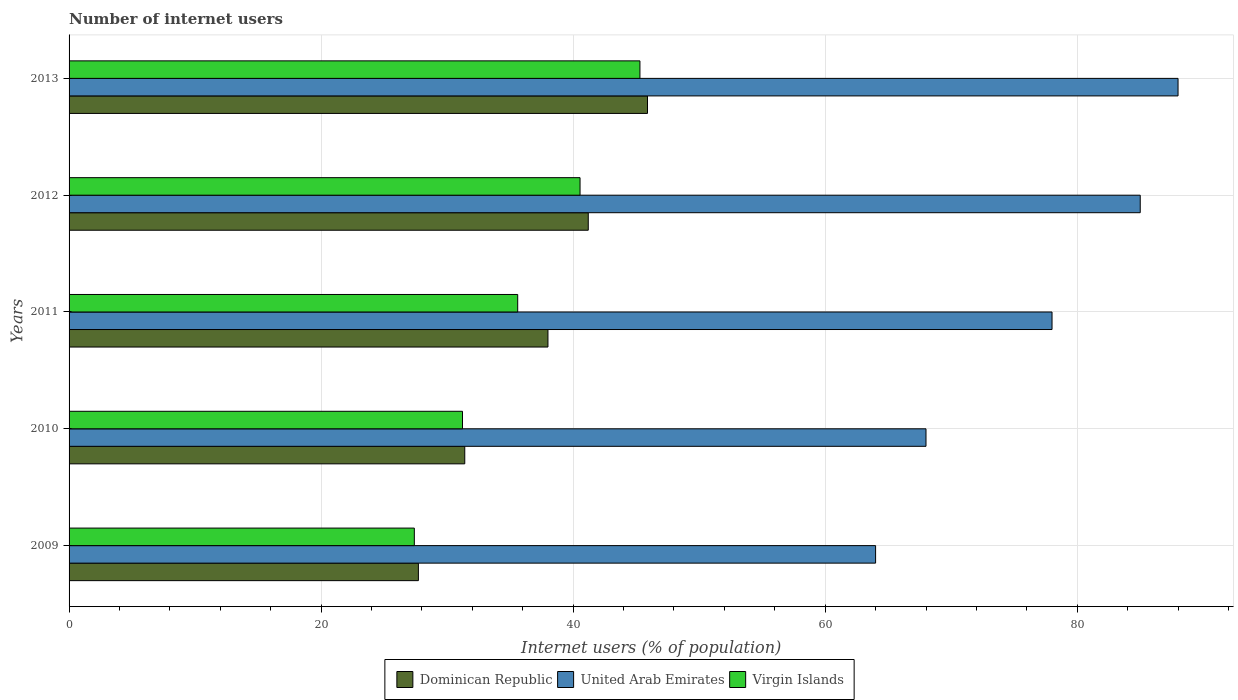How many different coloured bars are there?
Ensure brevity in your answer.  3. How many bars are there on the 3rd tick from the bottom?
Ensure brevity in your answer.  3. What is the label of the 3rd group of bars from the top?
Provide a succinct answer. 2011. In how many cases, is the number of bars for a given year not equal to the number of legend labels?
Offer a terse response. 0. What is the number of internet users in Virgin Islands in 2010?
Your answer should be compact. 31.22. Across all years, what is the maximum number of internet users in Dominican Republic?
Keep it short and to the point. 45.9. Across all years, what is the minimum number of internet users in Virgin Islands?
Make the answer very short. 27.4. What is the total number of internet users in United Arab Emirates in the graph?
Give a very brief answer. 383. What is the difference between the number of internet users in Dominican Republic in 2011 and that in 2013?
Your answer should be very brief. -7.9. What is the difference between the number of internet users in Virgin Islands in 2009 and the number of internet users in United Arab Emirates in 2012?
Your answer should be compact. -57.6. What is the average number of internet users in Virgin Islands per year?
Ensure brevity in your answer.  36.01. In the year 2012, what is the difference between the number of internet users in Dominican Republic and number of internet users in United Arab Emirates?
Offer a very short reply. -43.8. What is the ratio of the number of internet users in Virgin Islands in 2010 to that in 2011?
Provide a short and direct response. 0.88. What is the difference between the highest and the second highest number of internet users in Virgin Islands?
Make the answer very short. 4.75. What is the difference between the highest and the lowest number of internet users in Dominican Republic?
Give a very brief answer. 18.18. In how many years, is the number of internet users in Dominican Republic greater than the average number of internet users in Dominican Republic taken over all years?
Keep it short and to the point. 3. What does the 1st bar from the top in 2009 represents?
Your answer should be very brief. Virgin Islands. What does the 3rd bar from the bottom in 2012 represents?
Make the answer very short. Virgin Islands. How many bars are there?
Your answer should be compact. 15. Are all the bars in the graph horizontal?
Give a very brief answer. Yes. What is the difference between two consecutive major ticks on the X-axis?
Offer a terse response. 20. Are the values on the major ticks of X-axis written in scientific E-notation?
Your answer should be very brief. No. Where does the legend appear in the graph?
Your answer should be compact. Bottom center. How many legend labels are there?
Make the answer very short. 3. How are the legend labels stacked?
Your response must be concise. Horizontal. What is the title of the graph?
Your answer should be compact. Number of internet users. Does "Senegal" appear as one of the legend labels in the graph?
Keep it short and to the point. No. What is the label or title of the X-axis?
Make the answer very short. Internet users (% of population). What is the Internet users (% of population) in Dominican Republic in 2009?
Offer a terse response. 27.72. What is the Internet users (% of population) in Virgin Islands in 2009?
Offer a very short reply. 27.4. What is the Internet users (% of population) of Dominican Republic in 2010?
Keep it short and to the point. 31.4. What is the Internet users (% of population) of Virgin Islands in 2010?
Make the answer very short. 31.22. What is the Internet users (% of population) in Dominican Republic in 2011?
Your response must be concise. 38. What is the Internet users (% of population) in United Arab Emirates in 2011?
Offer a very short reply. 78. What is the Internet users (% of population) in Virgin Islands in 2011?
Your answer should be compact. 35.6. What is the Internet users (% of population) in Dominican Republic in 2012?
Offer a terse response. 41.2. What is the Internet users (% of population) in United Arab Emirates in 2012?
Your answer should be compact. 85. What is the Internet users (% of population) in Virgin Islands in 2012?
Keep it short and to the point. 40.55. What is the Internet users (% of population) of Dominican Republic in 2013?
Your answer should be very brief. 45.9. What is the Internet users (% of population) of United Arab Emirates in 2013?
Your answer should be very brief. 88. What is the Internet users (% of population) in Virgin Islands in 2013?
Offer a very short reply. 45.3. Across all years, what is the maximum Internet users (% of population) in Dominican Republic?
Give a very brief answer. 45.9. Across all years, what is the maximum Internet users (% of population) in United Arab Emirates?
Offer a very short reply. 88. Across all years, what is the maximum Internet users (% of population) in Virgin Islands?
Your answer should be compact. 45.3. Across all years, what is the minimum Internet users (% of population) of Dominican Republic?
Offer a very short reply. 27.72. Across all years, what is the minimum Internet users (% of population) in United Arab Emirates?
Ensure brevity in your answer.  64. Across all years, what is the minimum Internet users (% of population) of Virgin Islands?
Provide a succinct answer. 27.4. What is the total Internet users (% of population) in Dominican Republic in the graph?
Make the answer very short. 184.22. What is the total Internet users (% of population) of United Arab Emirates in the graph?
Your response must be concise. 383. What is the total Internet users (% of population) in Virgin Islands in the graph?
Offer a very short reply. 180.06. What is the difference between the Internet users (% of population) in Dominican Republic in 2009 and that in 2010?
Your answer should be very brief. -3.68. What is the difference between the Internet users (% of population) of United Arab Emirates in 2009 and that in 2010?
Offer a terse response. -4. What is the difference between the Internet users (% of population) in Virgin Islands in 2009 and that in 2010?
Keep it short and to the point. -3.82. What is the difference between the Internet users (% of population) in Dominican Republic in 2009 and that in 2011?
Provide a succinct answer. -10.28. What is the difference between the Internet users (% of population) of Virgin Islands in 2009 and that in 2011?
Ensure brevity in your answer.  -8.2. What is the difference between the Internet users (% of population) in Dominican Republic in 2009 and that in 2012?
Provide a succinct answer. -13.48. What is the difference between the Internet users (% of population) of United Arab Emirates in 2009 and that in 2012?
Provide a succinct answer. -21. What is the difference between the Internet users (% of population) in Virgin Islands in 2009 and that in 2012?
Offer a very short reply. -13.15. What is the difference between the Internet users (% of population) in Dominican Republic in 2009 and that in 2013?
Provide a succinct answer. -18.18. What is the difference between the Internet users (% of population) in United Arab Emirates in 2009 and that in 2013?
Your response must be concise. -24. What is the difference between the Internet users (% of population) of Virgin Islands in 2009 and that in 2013?
Ensure brevity in your answer.  -17.9. What is the difference between the Internet users (% of population) of United Arab Emirates in 2010 and that in 2011?
Offer a very short reply. -10. What is the difference between the Internet users (% of population) of Virgin Islands in 2010 and that in 2011?
Provide a short and direct response. -4.38. What is the difference between the Internet users (% of population) of Virgin Islands in 2010 and that in 2012?
Give a very brief answer. -9.33. What is the difference between the Internet users (% of population) in Dominican Republic in 2010 and that in 2013?
Your answer should be very brief. -14.5. What is the difference between the Internet users (% of population) of United Arab Emirates in 2010 and that in 2013?
Give a very brief answer. -20. What is the difference between the Internet users (% of population) in Virgin Islands in 2010 and that in 2013?
Provide a short and direct response. -14.08. What is the difference between the Internet users (% of population) in United Arab Emirates in 2011 and that in 2012?
Your answer should be very brief. -7. What is the difference between the Internet users (% of population) of Virgin Islands in 2011 and that in 2012?
Your answer should be compact. -4.95. What is the difference between the Internet users (% of population) in Dominican Republic in 2011 and that in 2013?
Provide a short and direct response. -7.9. What is the difference between the Internet users (% of population) in United Arab Emirates in 2011 and that in 2013?
Your answer should be very brief. -10. What is the difference between the Internet users (% of population) of Dominican Republic in 2012 and that in 2013?
Offer a terse response. -4.7. What is the difference between the Internet users (% of population) in Virgin Islands in 2012 and that in 2013?
Provide a short and direct response. -4.75. What is the difference between the Internet users (% of population) in Dominican Republic in 2009 and the Internet users (% of population) in United Arab Emirates in 2010?
Offer a terse response. -40.28. What is the difference between the Internet users (% of population) in United Arab Emirates in 2009 and the Internet users (% of population) in Virgin Islands in 2010?
Your answer should be compact. 32.78. What is the difference between the Internet users (% of population) of Dominican Republic in 2009 and the Internet users (% of population) of United Arab Emirates in 2011?
Offer a terse response. -50.28. What is the difference between the Internet users (% of population) in Dominican Republic in 2009 and the Internet users (% of population) in Virgin Islands in 2011?
Ensure brevity in your answer.  -7.88. What is the difference between the Internet users (% of population) in United Arab Emirates in 2009 and the Internet users (% of population) in Virgin Islands in 2011?
Your response must be concise. 28.4. What is the difference between the Internet users (% of population) of Dominican Republic in 2009 and the Internet users (% of population) of United Arab Emirates in 2012?
Your answer should be very brief. -57.28. What is the difference between the Internet users (% of population) of Dominican Republic in 2009 and the Internet users (% of population) of Virgin Islands in 2012?
Give a very brief answer. -12.83. What is the difference between the Internet users (% of population) of United Arab Emirates in 2009 and the Internet users (% of population) of Virgin Islands in 2012?
Provide a succinct answer. 23.45. What is the difference between the Internet users (% of population) of Dominican Republic in 2009 and the Internet users (% of population) of United Arab Emirates in 2013?
Offer a very short reply. -60.28. What is the difference between the Internet users (% of population) in Dominican Republic in 2009 and the Internet users (% of population) in Virgin Islands in 2013?
Provide a succinct answer. -17.58. What is the difference between the Internet users (% of population) of Dominican Republic in 2010 and the Internet users (% of population) of United Arab Emirates in 2011?
Provide a short and direct response. -46.6. What is the difference between the Internet users (% of population) of Dominican Republic in 2010 and the Internet users (% of population) of Virgin Islands in 2011?
Offer a very short reply. -4.2. What is the difference between the Internet users (% of population) of United Arab Emirates in 2010 and the Internet users (% of population) of Virgin Islands in 2011?
Your answer should be very brief. 32.4. What is the difference between the Internet users (% of population) of Dominican Republic in 2010 and the Internet users (% of population) of United Arab Emirates in 2012?
Keep it short and to the point. -53.6. What is the difference between the Internet users (% of population) of Dominican Republic in 2010 and the Internet users (% of population) of Virgin Islands in 2012?
Your answer should be very brief. -9.15. What is the difference between the Internet users (% of population) in United Arab Emirates in 2010 and the Internet users (% of population) in Virgin Islands in 2012?
Keep it short and to the point. 27.45. What is the difference between the Internet users (% of population) of Dominican Republic in 2010 and the Internet users (% of population) of United Arab Emirates in 2013?
Give a very brief answer. -56.6. What is the difference between the Internet users (% of population) of Dominican Republic in 2010 and the Internet users (% of population) of Virgin Islands in 2013?
Your response must be concise. -13.9. What is the difference between the Internet users (% of population) of United Arab Emirates in 2010 and the Internet users (% of population) of Virgin Islands in 2013?
Your answer should be compact. 22.7. What is the difference between the Internet users (% of population) in Dominican Republic in 2011 and the Internet users (% of population) in United Arab Emirates in 2012?
Make the answer very short. -47. What is the difference between the Internet users (% of population) of Dominican Republic in 2011 and the Internet users (% of population) of Virgin Islands in 2012?
Keep it short and to the point. -2.55. What is the difference between the Internet users (% of population) in United Arab Emirates in 2011 and the Internet users (% of population) in Virgin Islands in 2012?
Give a very brief answer. 37.45. What is the difference between the Internet users (% of population) in Dominican Republic in 2011 and the Internet users (% of population) in Virgin Islands in 2013?
Your response must be concise. -7.3. What is the difference between the Internet users (% of population) in United Arab Emirates in 2011 and the Internet users (% of population) in Virgin Islands in 2013?
Provide a short and direct response. 32.7. What is the difference between the Internet users (% of population) of Dominican Republic in 2012 and the Internet users (% of population) of United Arab Emirates in 2013?
Provide a short and direct response. -46.8. What is the difference between the Internet users (% of population) in Dominican Republic in 2012 and the Internet users (% of population) in Virgin Islands in 2013?
Ensure brevity in your answer.  -4.1. What is the difference between the Internet users (% of population) of United Arab Emirates in 2012 and the Internet users (% of population) of Virgin Islands in 2013?
Give a very brief answer. 39.7. What is the average Internet users (% of population) of Dominican Republic per year?
Offer a terse response. 36.84. What is the average Internet users (% of population) in United Arab Emirates per year?
Provide a short and direct response. 76.6. What is the average Internet users (% of population) of Virgin Islands per year?
Keep it short and to the point. 36.01. In the year 2009, what is the difference between the Internet users (% of population) of Dominican Republic and Internet users (% of population) of United Arab Emirates?
Ensure brevity in your answer.  -36.28. In the year 2009, what is the difference between the Internet users (% of population) of Dominican Republic and Internet users (% of population) of Virgin Islands?
Your answer should be very brief. 0.32. In the year 2009, what is the difference between the Internet users (% of population) in United Arab Emirates and Internet users (% of population) in Virgin Islands?
Make the answer very short. 36.6. In the year 2010, what is the difference between the Internet users (% of population) in Dominican Republic and Internet users (% of population) in United Arab Emirates?
Provide a short and direct response. -36.6. In the year 2010, what is the difference between the Internet users (% of population) of Dominican Republic and Internet users (% of population) of Virgin Islands?
Your response must be concise. 0.18. In the year 2010, what is the difference between the Internet users (% of population) of United Arab Emirates and Internet users (% of population) of Virgin Islands?
Give a very brief answer. 36.78. In the year 2011, what is the difference between the Internet users (% of population) of Dominican Republic and Internet users (% of population) of Virgin Islands?
Offer a very short reply. 2.4. In the year 2011, what is the difference between the Internet users (% of population) in United Arab Emirates and Internet users (% of population) in Virgin Islands?
Make the answer very short. 42.4. In the year 2012, what is the difference between the Internet users (% of population) in Dominican Republic and Internet users (% of population) in United Arab Emirates?
Offer a very short reply. -43.8. In the year 2012, what is the difference between the Internet users (% of population) in Dominican Republic and Internet users (% of population) in Virgin Islands?
Provide a short and direct response. 0.65. In the year 2012, what is the difference between the Internet users (% of population) of United Arab Emirates and Internet users (% of population) of Virgin Islands?
Ensure brevity in your answer.  44.45. In the year 2013, what is the difference between the Internet users (% of population) in Dominican Republic and Internet users (% of population) in United Arab Emirates?
Provide a succinct answer. -42.1. In the year 2013, what is the difference between the Internet users (% of population) of United Arab Emirates and Internet users (% of population) of Virgin Islands?
Give a very brief answer. 42.7. What is the ratio of the Internet users (% of population) of Dominican Republic in 2009 to that in 2010?
Provide a short and direct response. 0.88. What is the ratio of the Internet users (% of population) of Virgin Islands in 2009 to that in 2010?
Provide a succinct answer. 0.88. What is the ratio of the Internet users (% of population) of Dominican Republic in 2009 to that in 2011?
Keep it short and to the point. 0.73. What is the ratio of the Internet users (% of population) of United Arab Emirates in 2009 to that in 2011?
Keep it short and to the point. 0.82. What is the ratio of the Internet users (% of population) of Virgin Islands in 2009 to that in 2011?
Give a very brief answer. 0.77. What is the ratio of the Internet users (% of population) in Dominican Republic in 2009 to that in 2012?
Your answer should be very brief. 0.67. What is the ratio of the Internet users (% of population) in United Arab Emirates in 2009 to that in 2012?
Offer a terse response. 0.75. What is the ratio of the Internet users (% of population) of Virgin Islands in 2009 to that in 2012?
Make the answer very short. 0.68. What is the ratio of the Internet users (% of population) in Dominican Republic in 2009 to that in 2013?
Offer a terse response. 0.6. What is the ratio of the Internet users (% of population) in United Arab Emirates in 2009 to that in 2013?
Ensure brevity in your answer.  0.73. What is the ratio of the Internet users (% of population) of Virgin Islands in 2009 to that in 2013?
Offer a terse response. 0.6. What is the ratio of the Internet users (% of population) of Dominican Republic in 2010 to that in 2011?
Provide a short and direct response. 0.83. What is the ratio of the Internet users (% of population) in United Arab Emirates in 2010 to that in 2011?
Your response must be concise. 0.87. What is the ratio of the Internet users (% of population) in Virgin Islands in 2010 to that in 2011?
Provide a succinct answer. 0.88. What is the ratio of the Internet users (% of population) of Dominican Republic in 2010 to that in 2012?
Your answer should be very brief. 0.76. What is the ratio of the Internet users (% of population) in United Arab Emirates in 2010 to that in 2012?
Provide a succinct answer. 0.8. What is the ratio of the Internet users (% of population) of Virgin Islands in 2010 to that in 2012?
Offer a very short reply. 0.77. What is the ratio of the Internet users (% of population) in Dominican Republic in 2010 to that in 2013?
Give a very brief answer. 0.68. What is the ratio of the Internet users (% of population) in United Arab Emirates in 2010 to that in 2013?
Offer a very short reply. 0.77. What is the ratio of the Internet users (% of population) of Virgin Islands in 2010 to that in 2013?
Your answer should be very brief. 0.69. What is the ratio of the Internet users (% of population) in Dominican Republic in 2011 to that in 2012?
Ensure brevity in your answer.  0.92. What is the ratio of the Internet users (% of population) of United Arab Emirates in 2011 to that in 2012?
Make the answer very short. 0.92. What is the ratio of the Internet users (% of population) in Virgin Islands in 2011 to that in 2012?
Keep it short and to the point. 0.88. What is the ratio of the Internet users (% of population) in Dominican Republic in 2011 to that in 2013?
Keep it short and to the point. 0.83. What is the ratio of the Internet users (% of population) in United Arab Emirates in 2011 to that in 2013?
Your response must be concise. 0.89. What is the ratio of the Internet users (% of population) in Virgin Islands in 2011 to that in 2013?
Provide a succinct answer. 0.79. What is the ratio of the Internet users (% of population) in Dominican Republic in 2012 to that in 2013?
Your answer should be compact. 0.9. What is the ratio of the Internet users (% of population) in United Arab Emirates in 2012 to that in 2013?
Make the answer very short. 0.97. What is the ratio of the Internet users (% of population) in Virgin Islands in 2012 to that in 2013?
Offer a very short reply. 0.9. What is the difference between the highest and the second highest Internet users (% of population) in Dominican Republic?
Ensure brevity in your answer.  4.7. What is the difference between the highest and the second highest Internet users (% of population) in Virgin Islands?
Provide a short and direct response. 4.75. What is the difference between the highest and the lowest Internet users (% of population) of Dominican Republic?
Provide a short and direct response. 18.18. What is the difference between the highest and the lowest Internet users (% of population) in Virgin Islands?
Ensure brevity in your answer.  17.9. 